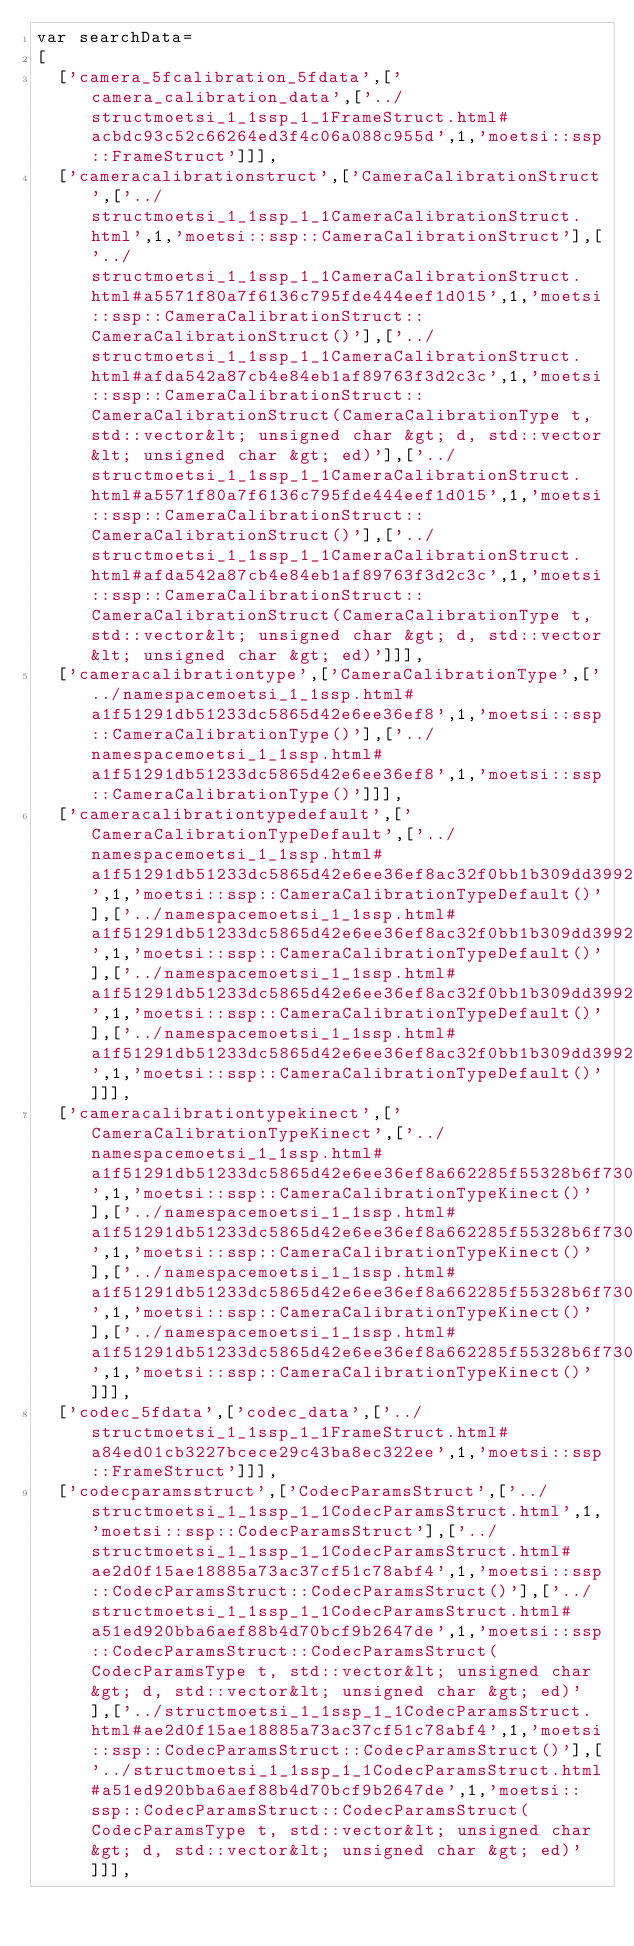<code> <loc_0><loc_0><loc_500><loc_500><_JavaScript_>var searchData=
[
  ['camera_5fcalibration_5fdata',['camera_calibration_data',['../structmoetsi_1_1ssp_1_1FrameStruct.html#acbdc93c52c66264ed3f4c06a088c955d',1,'moetsi::ssp::FrameStruct']]],
  ['cameracalibrationstruct',['CameraCalibrationStruct',['../structmoetsi_1_1ssp_1_1CameraCalibrationStruct.html',1,'moetsi::ssp::CameraCalibrationStruct'],['../structmoetsi_1_1ssp_1_1CameraCalibrationStruct.html#a5571f80a7f6136c795fde444eef1d015',1,'moetsi::ssp::CameraCalibrationStruct::CameraCalibrationStruct()'],['../structmoetsi_1_1ssp_1_1CameraCalibrationStruct.html#afda542a87cb4e84eb1af89763f3d2c3c',1,'moetsi::ssp::CameraCalibrationStruct::CameraCalibrationStruct(CameraCalibrationType t, std::vector&lt; unsigned char &gt; d, std::vector&lt; unsigned char &gt; ed)'],['../structmoetsi_1_1ssp_1_1CameraCalibrationStruct.html#a5571f80a7f6136c795fde444eef1d015',1,'moetsi::ssp::CameraCalibrationStruct::CameraCalibrationStruct()'],['../structmoetsi_1_1ssp_1_1CameraCalibrationStruct.html#afda542a87cb4e84eb1af89763f3d2c3c',1,'moetsi::ssp::CameraCalibrationStruct::CameraCalibrationStruct(CameraCalibrationType t, std::vector&lt; unsigned char &gt; d, std::vector&lt; unsigned char &gt; ed)']]],
  ['cameracalibrationtype',['CameraCalibrationType',['../namespacemoetsi_1_1ssp.html#a1f51291db51233dc5865d42e6ee36ef8',1,'moetsi::ssp::CameraCalibrationType()'],['../namespacemoetsi_1_1ssp.html#a1f51291db51233dc5865d42e6ee36ef8',1,'moetsi::ssp::CameraCalibrationType()']]],
  ['cameracalibrationtypedefault',['CameraCalibrationTypeDefault',['../namespacemoetsi_1_1ssp.html#a1f51291db51233dc5865d42e6ee36ef8ac32f0bb1b309dd3992d8e37bfaa00c78',1,'moetsi::ssp::CameraCalibrationTypeDefault()'],['../namespacemoetsi_1_1ssp.html#a1f51291db51233dc5865d42e6ee36ef8ac32f0bb1b309dd3992d8e37bfaa00c78',1,'moetsi::ssp::CameraCalibrationTypeDefault()'],['../namespacemoetsi_1_1ssp.html#a1f51291db51233dc5865d42e6ee36ef8ac32f0bb1b309dd3992d8e37bfaa00c78',1,'moetsi::ssp::CameraCalibrationTypeDefault()'],['../namespacemoetsi_1_1ssp.html#a1f51291db51233dc5865d42e6ee36ef8ac32f0bb1b309dd3992d8e37bfaa00c78',1,'moetsi::ssp::CameraCalibrationTypeDefault()']]],
  ['cameracalibrationtypekinect',['CameraCalibrationTypeKinect',['../namespacemoetsi_1_1ssp.html#a1f51291db51233dc5865d42e6ee36ef8a662285f55328b6f7305456b86b8056bb',1,'moetsi::ssp::CameraCalibrationTypeKinect()'],['../namespacemoetsi_1_1ssp.html#a1f51291db51233dc5865d42e6ee36ef8a662285f55328b6f7305456b86b8056bb',1,'moetsi::ssp::CameraCalibrationTypeKinect()'],['../namespacemoetsi_1_1ssp.html#a1f51291db51233dc5865d42e6ee36ef8a662285f55328b6f7305456b86b8056bb',1,'moetsi::ssp::CameraCalibrationTypeKinect()'],['../namespacemoetsi_1_1ssp.html#a1f51291db51233dc5865d42e6ee36ef8a662285f55328b6f7305456b86b8056bb',1,'moetsi::ssp::CameraCalibrationTypeKinect()']]],
  ['codec_5fdata',['codec_data',['../structmoetsi_1_1ssp_1_1FrameStruct.html#a84ed01cb3227bcece29c43ba8ec322ee',1,'moetsi::ssp::FrameStruct']]],
  ['codecparamsstruct',['CodecParamsStruct',['../structmoetsi_1_1ssp_1_1CodecParamsStruct.html',1,'moetsi::ssp::CodecParamsStruct'],['../structmoetsi_1_1ssp_1_1CodecParamsStruct.html#ae2d0f15ae18885a73ac37cf51c78abf4',1,'moetsi::ssp::CodecParamsStruct::CodecParamsStruct()'],['../structmoetsi_1_1ssp_1_1CodecParamsStruct.html#a51ed920bba6aef88b4d70bcf9b2647de',1,'moetsi::ssp::CodecParamsStruct::CodecParamsStruct(CodecParamsType t, std::vector&lt; unsigned char &gt; d, std::vector&lt; unsigned char &gt; ed)'],['../structmoetsi_1_1ssp_1_1CodecParamsStruct.html#ae2d0f15ae18885a73ac37cf51c78abf4',1,'moetsi::ssp::CodecParamsStruct::CodecParamsStruct()'],['../structmoetsi_1_1ssp_1_1CodecParamsStruct.html#a51ed920bba6aef88b4d70bcf9b2647de',1,'moetsi::ssp::CodecParamsStruct::CodecParamsStruct(CodecParamsType t, std::vector&lt; unsigned char &gt; d, std::vector&lt; unsigned char &gt; ed)']]],</code> 